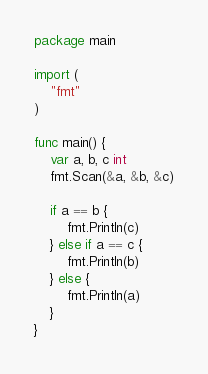Convert code to text. <code><loc_0><loc_0><loc_500><loc_500><_Go_>package main

import (
	"fmt"
)

func main() {
	var a, b, c int
	fmt.Scan(&a, &b, &c)

	if a == b {
		fmt.Println(c)
	} else if a == c {
		fmt.Println(b)
	} else {
		fmt.Println(a)
	}
}
</code> 